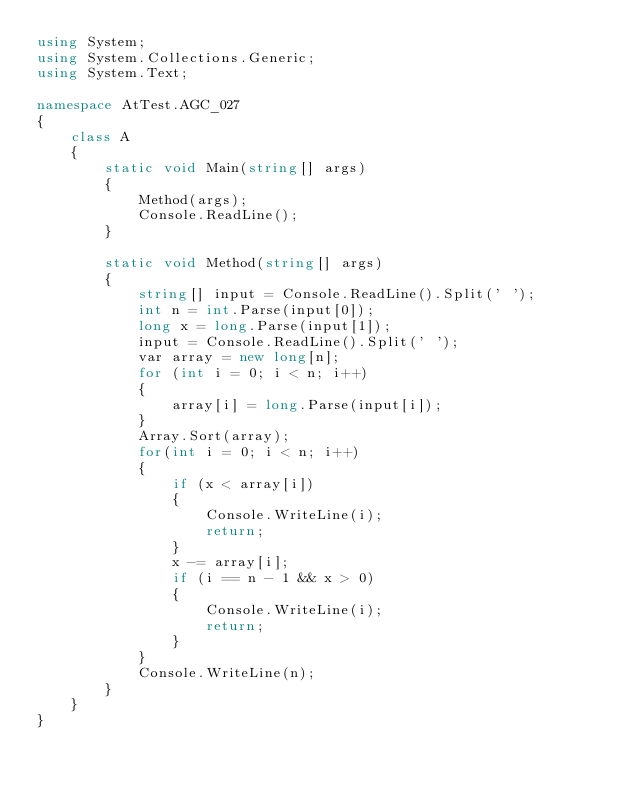<code> <loc_0><loc_0><loc_500><loc_500><_C#_>using System;
using System.Collections.Generic;
using System.Text;

namespace AtTest.AGC_027
{
    class A
    {
        static void Main(string[] args)
        {
            Method(args);
            Console.ReadLine();
        }

        static void Method(string[] args)
        {
            string[] input = Console.ReadLine().Split(' ');
            int n = int.Parse(input[0]);
            long x = long.Parse(input[1]);
            input = Console.ReadLine().Split(' ');
            var array = new long[n];
            for (int i = 0; i < n; i++)
            {
                array[i] = long.Parse(input[i]);
            }
            Array.Sort(array);
            for(int i = 0; i < n; i++)
            {
                if (x < array[i])
                {
                    Console.WriteLine(i);
                    return;
                }
                x -= array[i];
                if (i == n - 1 && x > 0)
                {
                    Console.WriteLine(i);
                    return;
                }
            }
            Console.WriteLine(n);
        }
    }
}
</code> 